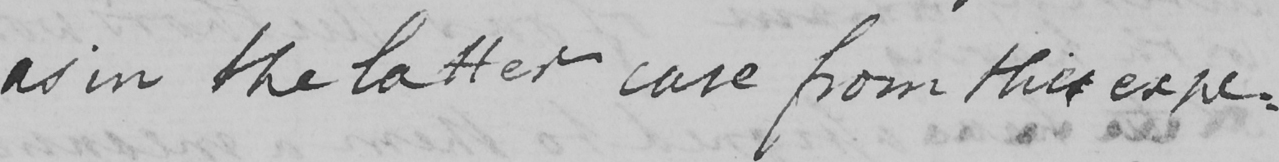Can you read and transcribe this handwriting? as in the latter case from this expe : 